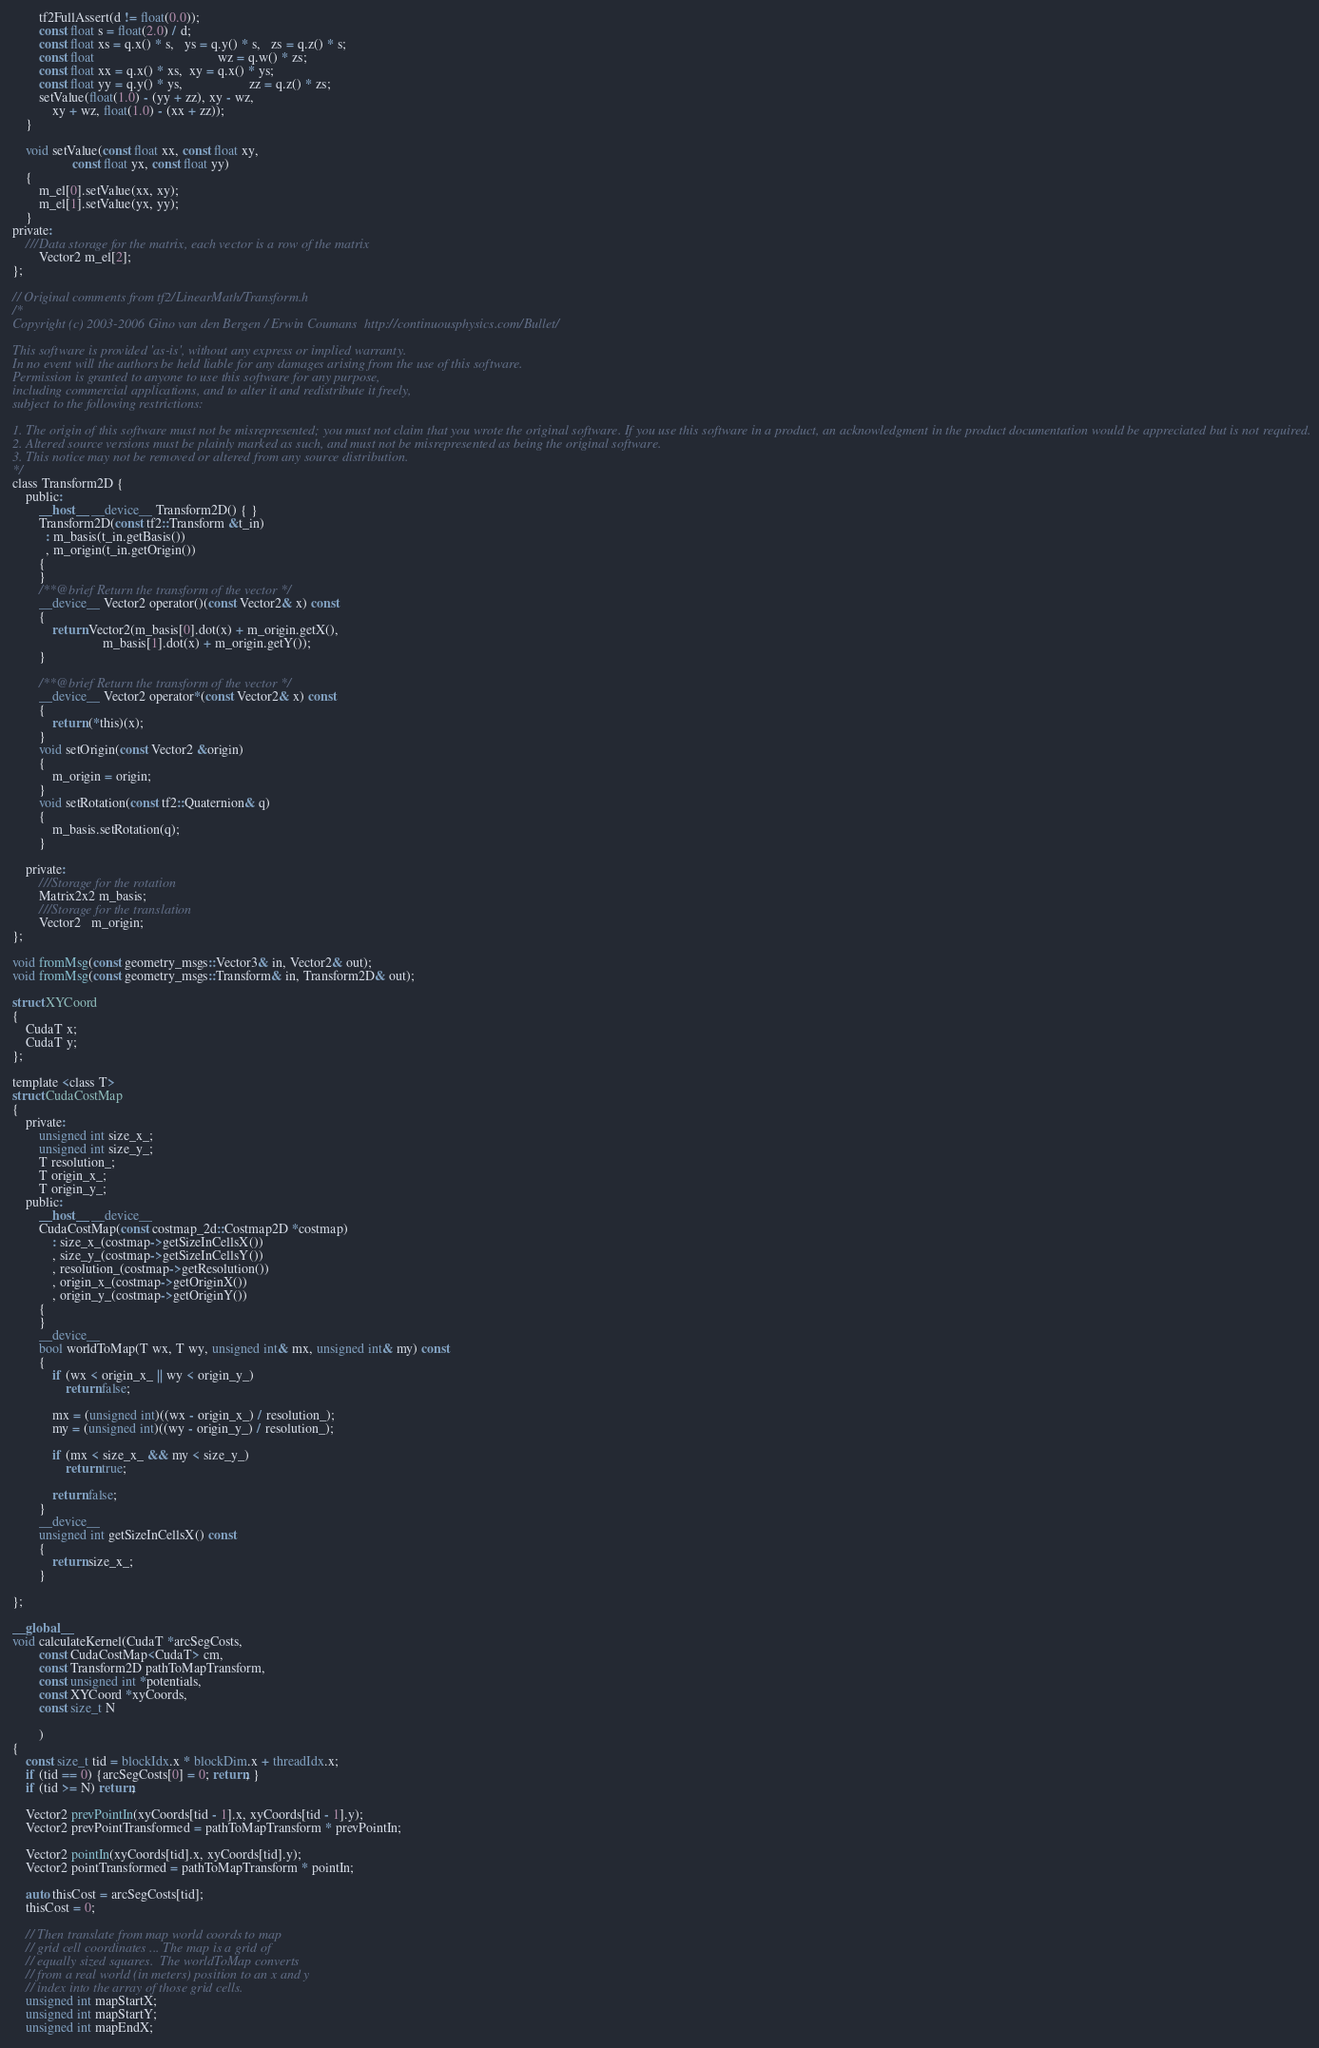Convert code to text. <code><loc_0><loc_0><loc_500><loc_500><_Cuda_>		tf2FullAssert(d != float(0.0));
		const float s = float(2.0) / d;
		const float xs = q.x() * s,   ys = q.y() * s,   zs = q.z() * s;
		const float                                     wz = q.w() * zs;
		const float xx = q.x() * xs,  xy = q.x() * ys;
		const float yy = q.y() * ys,                    zz = q.z() * zs;
		setValue(float(1.0) - (yy + zz), xy - wz,
			xy + wz, float(1.0) - (xx + zz));
	}

	void setValue(const float xx, const float xy,
				  const float yx, const float yy)
	{
		m_el[0].setValue(xx, xy);
		m_el[1].setValue(yx, yy);
	}
private:
	///Data storage for the matrix, each vector is a row of the matrix
		Vector2 m_el[2];
};

// Original comments from tf2/LinearMath/Transform.h
/*
Copyright (c) 2003-2006 Gino van den Bergen / Erwin Coumans  http://continuousphysics.com/Bullet/

This software is provided 'as-is', without any express or implied warranty.
In no event will the authors be held liable for any damages arising from the use of this software.
Permission is granted to anyone to use this software for any purpose,
including commercial applications, and to alter it and redistribute it freely,
subject to the following restrictions:

1. The origin of this software must not be misrepresented; you must not claim that you wrote the original software. If you use this software in a product, an acknowledgment in the product documentation would be appreciated but is not required.
2. Altered source versions must be plainly marked as such, and must not be misrepresented as being the original software.
3. This notice may not be removed or altered from any source distribution.
*/
class Transform2D {
	public:
		__host__ __device__ Transform2D() { }
		Transform2D(const tf2::Transform &t_in)
		  : m_basis(t_in.getBasis())
		  , m_origin(t_in.getOrigin())
		{
		}
		/**@brief Return the transform of the vector */
		__device__ Vector2 operator()(const Vector2& x) const
		{
			return Vector2(m_basis[0].dot(x) + m_origin.getX(),
						   m_basis[1].dot(x) + m_origin.getY());
		}

		/**@brief Return the transform of the vector */
		__device__ Vector2 operator*(const Vector2& x) const
		{
			return (*this)(x);
		}
		void setOrigin(const Vector2 &origin)
		{
			m_origin = origin;
		}
		void setRotation(const tf2::Quaternion& q)
		{
			m_basis.setRotation(q);
		}

	private:
		///Storage for the rotation
		Matrix2x2 m_basis;
		///Storage for the translation
		Vector2   m_origin;
};

void fromMsg(const geometry_msgs::Vector3& in, Vector2& out);
void fromMsg(const geometry_msgs::Transform& in, Transform2D& out);

struct XYCoord
{
	CudaT x;
	CudaT y;
};

template <class T>
struct CudaCostMap
{
	private:
		unsigned int size_x_;
		unsigned int size_y_;
		T resolution_;
		T origin_x_;
		T origin_y_;
	public:
		__host__ __device__
		CudaCostMap(const costmap_2d::Costmap2D *costmap)
			: size_x_(costmap->getSizeInCellsX())
			, size_y_(costmap->getSizeInCellsY())
			, resolution_(costmap->getResolution())
			, origin_x_(costmap->getOriginX())
			, origin_y_(costmap->getOriginY())
		{
		}
		__device__
		bool worldToMap(T wx, T wy, unsigned int& mx, unsigned int& my) const
		{
			if (wx < origin_x_ || wy < origin_y_)
				return false;

			mx = (unsigned int)((wx - origin_x_) / resolution_);
			my = (unsigned int)((wy - origin_y_) / resolution_);

			if (mx < size_x_ && my < size_y_)
				return true;

			return false;
		}
		__device__
		unsigned int getSizeInCellsX() const
		{
			return size_x_;
		}

};

__global__
void calculateKernel(CudaT *arcSegCosts,
		const CudaCostMap<CudaT> cm,
		const Transform2D pathToMapTransform,
		const unsigned int *potentials,
		const XYCoord *xyCoords,
		const size_t N

		)
{
	const size_t tid = blockIdx.x * blockDim.x + threadIdx.x;
	if (tid == 0) {arcSegCosts[0] = 0; return; }
	if (tid >= N) return;

	Vector2 prevPointIn(xyCoords[tid - 1].x, xyCoords[tid - 1].y);
	Vector2 prevPointTransformed = pathToMapTransform * prevPointIn;

	Vector2 pointIn(xyCoords[tid].x, xyCoords[tid].y);
	Vector2 pointTransformed = pathToMapTransform * pointIn;

	auto thisCost = arcSegCosts[tid];
	thisCost = 0;

	// Then translate from map world coords to map
	// grid cell coordinates ... The map is a grid of
	// equally sized squares.  The worldToMap converts
	// from a real world (in meters) position to an x and y
	// index into the array of those grid cells.
	unsigned int mapStartX;
	unsigned int mapStartY;
	unsigned int mapEndX;</code> 